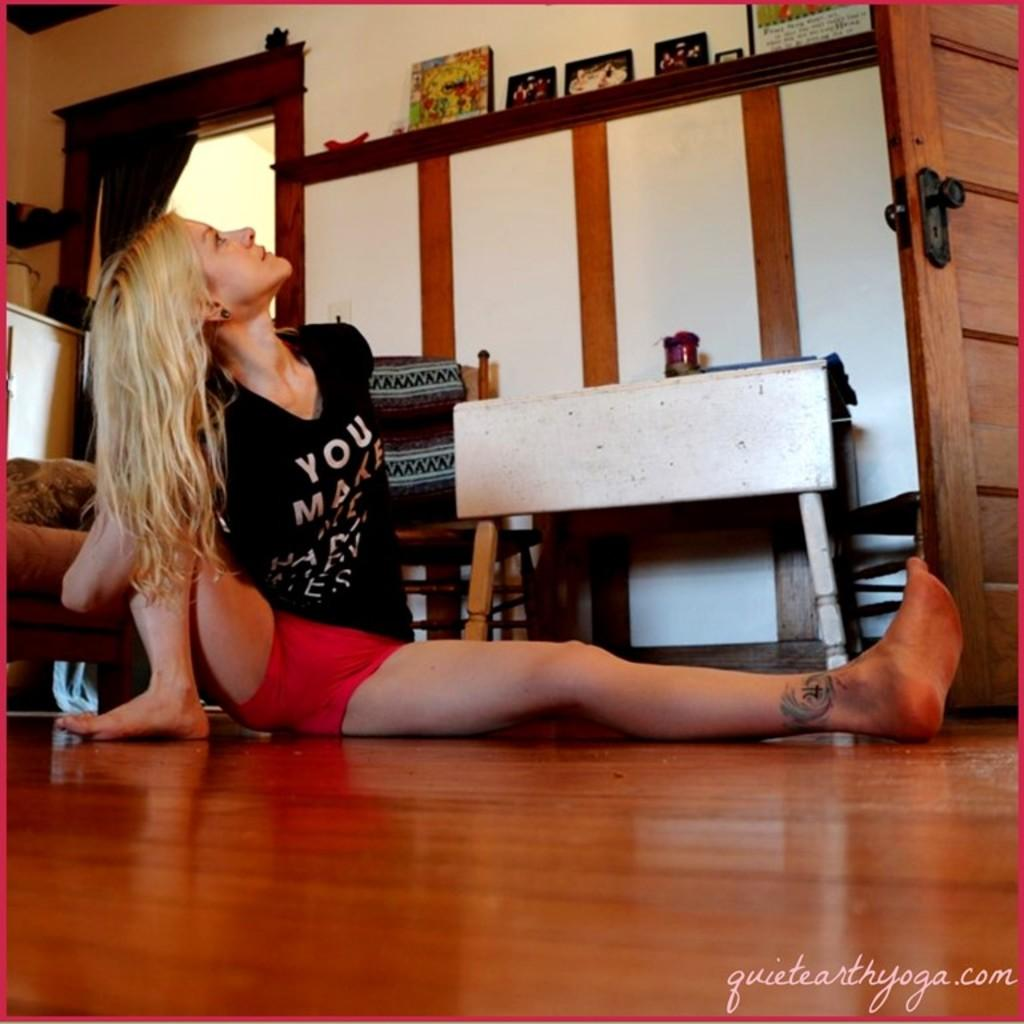Provide a one-sentence caption for the provided image. A woman wearing a black shirt that says you make looking up at the ceiling. 